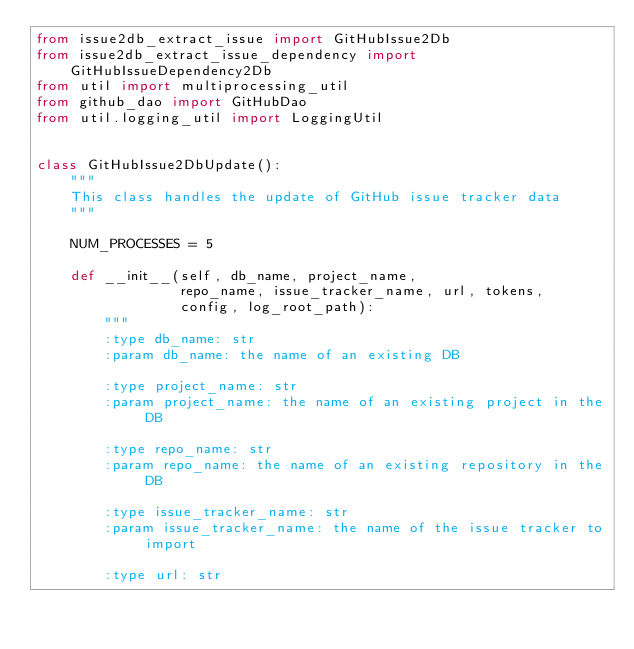Convert code to text. <code><loc_0><loc_0><loc_500><loc_500><_Python_>from issue2db_extract_issue import GitHubIssue2Db
from issue2db_extract_issue_dependency import GitHubIssueDependency2Db
from util import multiprocessing_util
from github_dao import GitHubDao
from util.logging_util import LoggingUtil


class GitHubIssue2DbUpdate():
    """
    This class handles the update of GitHub issue tracker data
    """

    NUM_PROCESSES = 5

    def __init__(self, db_name, project_name,
                 repo_name, issue_tracker_name, url, tokens,
                 config, log_root_path):
        """
        :type db_name: str
        :param db_name: the name of an existing DB

        :type project_name: str
        :param project_name: the name of an existing project in the DB

        :type repo_name: str
        :param repo_name: the name of an existing repository in the DB

        :type issue_tracker_name: str
        :param issue_tracker_name: the name of the issue tracker to import

        :type url: str</code> 